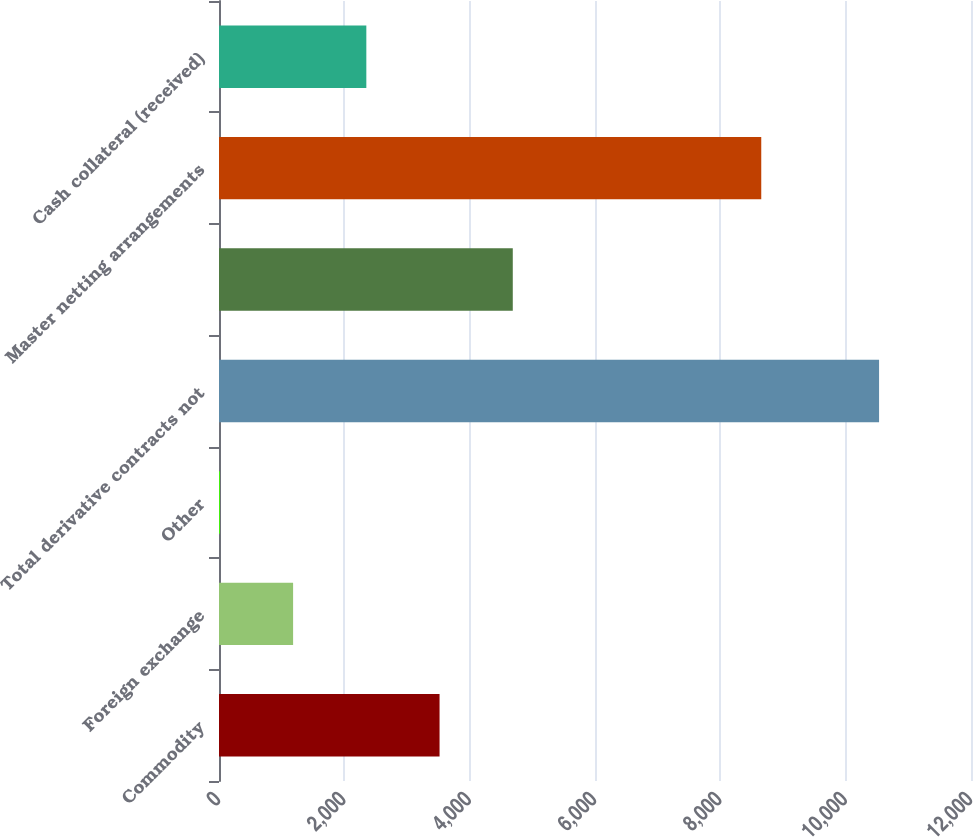Convert chart to OTSL. <chart><loc_0><loc_0><loc_500><loc_500><bar_chart><fcel>Commodity<fcel>Foreign exchange<fcel>Other<fcel>Total derivative contracts not<fcel>Unnamed: 4<fcel>Master netting arrangements<fcel>Cash collateral (received)<nl><fcel>3519.5<fcel>1182.5<fcel>14<fcel>10533<fcel>4688<fcel>8653<fcel>2351<nl></chart> 